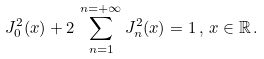<formula> <loc_0><loc_0><loc_500><loc_500>J _ { 0 } ^ { 2 } ( x ) + 2 \, \sum _ { n = 1 } ^ { n = + \infty } J _ { n } ^ { 2 } ( x ) = 1 \, , \, x \in \mathbb { R } \, .</formula> 